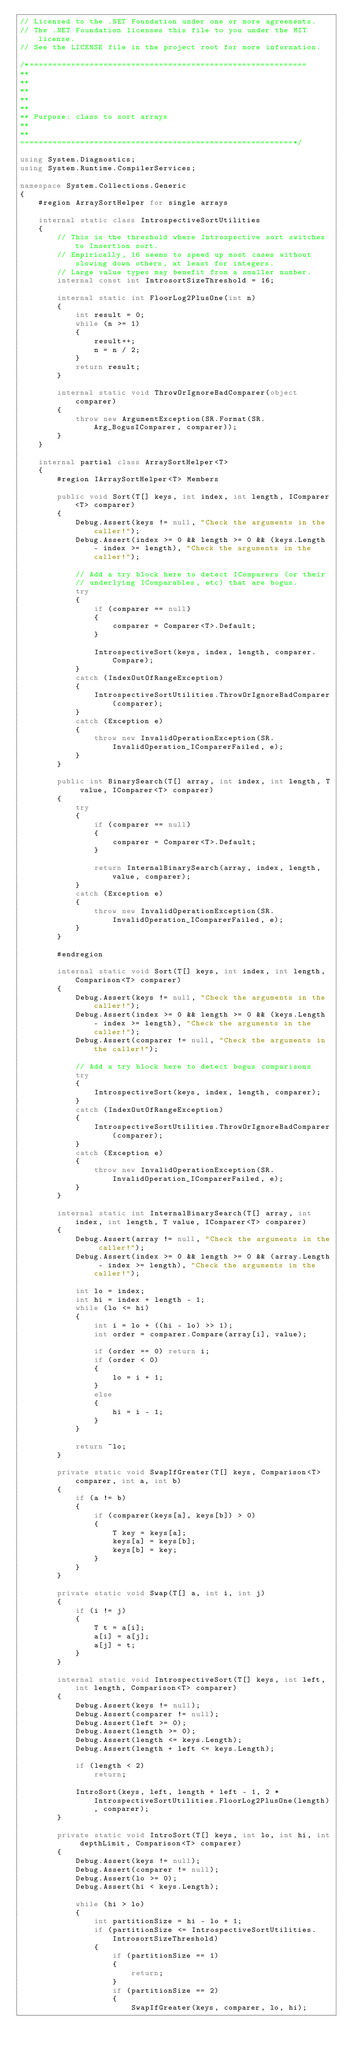Convert code to text. <code><loc_0><loc_0><loc_500><loc_500><_C#_>// Licensed to the .NET Foundation under one or more agreements.
// The .NET Foundation licenses this file to you under the MIT license.
// See the LICENSE file in the project root for more information.

/*============================================================
**
**
** 
**
**
** Purpose: class to sort arrays
**
** 
===========================================================*/

using System.Diagnostics;
using System.Runtime.CompilerServices;

namespace System.Collections.Generic
{
    #region ArraySortHelper for single arrays

    internal static class IntrospectiveSortUtilities
    {
        // This is the threshold where Introspective sort switches to Insertion sort.
        // Empirically, 16 seems to speed up most cases without slowing down others, at least for integers.
        // Large value types may benefit from a smaller number.
        internal const int IntrosortSizeThreshold = 16;

        internal static int FloorLog2PlusOne(int n)
        {
            int result = 0;
            while (n >= 1)
            {
                result++;
                n = n / 2;
            }
            return result;
        }

        internal static void ThrowOrIgnoreBadComparer(object comparer)
        {
            throw new ArgumentException(SR.Format(SR.Arg_BogusIComparer, comparer));
        }
    }

    internal partial class ArraySortHelper<T>
    {
        #region IArraySortHelper<T> Members

        public void Sort(T[] keys, int index, int length, IComparer<T> comparer)
        {
            Debug.Assert(keys != null, "Check the arguments in the caller!");
            Debug.Assert(index >= 0 && length >= 0 && (keys.Length - index >= length), "Check the arguments in the caller!");

            // Add a try block here to detect IComparers (or their
            // underlying IComparables, etc) that are bogus.
            try
            {
                if (comparer == null)
                {
                    comparer = Comparer<T>.Default;
                }

                IntrospectiveSort(keys, index, length, comparer.Compare);
            }
            catch (IndexOutOfRangeException)
            {
                IntrospectiveSortUtilities.ThrowOrIgnoreBadComparer(comparer);
            }
            catch (Exception e)
            {
                throw new InvalidOperationException(SR.InvalidOperation_IComparerFailed, e);
            }
        }

        public int BinarySearch(T[] array, int index, int length, T value, IComparer<T> comparer)
        {
            try
            {
                if (comparer == null)
                {
                    comparer = Comparer<T>.Default;
                }

                return InternalBinarySearch(array, index, length, value, comparer);
            }
            catch (Exception e)
            {
                throw new InvalidOperationException(SR.InvalidOperation_IComparerFailed, e);
            }
        }

        #endregion

        internal static void Sort(T[] keys, int index, int length, Comparison<T> comparer)
        {
            Debug.Assert(keys != null, "Check the arguments in the caller!");
            Debug.Assert(index >= 0 && length >= 0 && (keys.Length - index >= length), "Check the arguments in the caller!");
            Debug.Assert(comparer != null, "Check the arguments in the caller!");

            // Add a try block here to detect bogus comparisons
            try
            {
                IntrospectiveSort(keys, index, length, comparer);
            }
            catch (IndexOutOfRangeException)
            {
                IntrospectiveSortUtilities.ThrowOrIgnoreBadComparer(comparer);
            }
            catch (Exception e)
            {
                throw new InvalidOperationException(SR.InvalidOperation_IComparerFailed, e);
            }
        }

        internal static int InternalBinarySearch(T[] array, int index, int length, T value, IComparer<T> comparer)
        {
            Debug.Assert(array != null, "Check the arguments in the caller!");
            Debug.Assert(index >= 0 && length >= 0 && (array.Length - index >= length), "Check the arguments in the caller!");

            int lo = index;
            int hi = index + length - 1;
            while (lo <= hi)
            {
                int i = lo + ((hi - lo) >> 1);
                int order = comparer.Compare(array[i], value);

                if (order == 0) return i;
                if (order < 0)
                {
                    lo = i + 1;
                }
                else
                {
                    hi = i - 1;
                }
            }

            return ~lo;
        }

        private static void SwapIfGreater(T[] keys, Comparison<T> comparer, int a, int b)
        {
            if (a != b)
            {
                if (comparer(keys[a], keys[b]) > 0)
                {
                    T key = keys[a];
                    keys[a] = keys[b];
                    keys[b] = key;
                }
            }
        }

        private static void Swap(T[] a, int i, int j)
        {
            if (i != j)
            {
                T t = a[i];
                a[i] = a[j];
                a[j] = t;
            }
        }

        internal static void IntrospectiveSort(T[] keys, int left, int length, Comparison<T> comparer)
        {
            Debug.Assert(keys != null);
            Debug.Assert(comparer != null);
            Debug.Assert(left >= 0);
            Debug.Assert(length >= 0);
            Debug.Assert(length <= keys.Length);
            Debug.Assert(length + left <= keys.Length);

            if (length < 2)
                return;

            IntroSort(keys, left, length + left - 1, 2 * IntrospectiveSortUtilities.FloorLog2PlusOne(length), comparer);
        }

        private static void IntroSort(T[] keys, int lo, int hi, int depthLimit, Comparison<T> comparer)
        {
            Debug.Assert(keys != null);
            Debug.Assert(comparer != null);
            Debug.Assert(lo >= 0);
            Debug.Assert(hi < keys.Length);

            while (hi > lo)
            {
                int partitionSize = hi - lo + 1;
                if (partitionSize <= IntrospectiveSortUtilities.IntrosortSizeThreshold)
                {
                    if (partitionSize == 1)
                    {
                        return;
                    }
                    if (partitionSize == 2)
                    {
                        SwapIfGreater(keys, comparer, lo, hi);</code> 